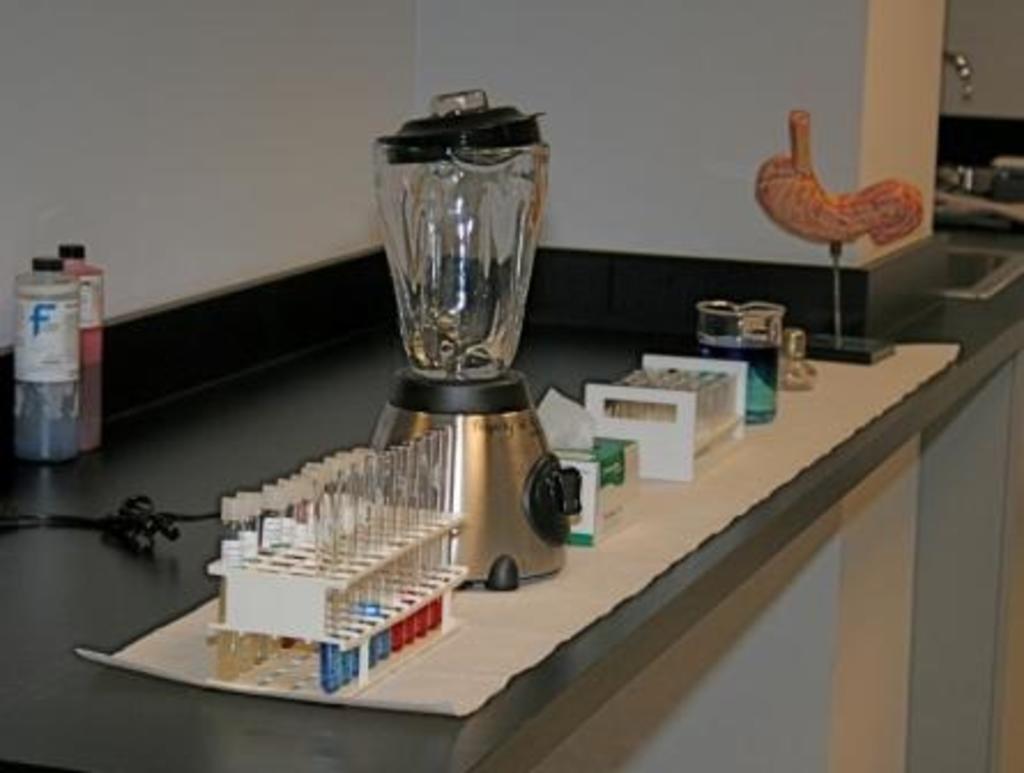Please provide a concise description of this image. I can see the test tubes, mixer with a jar, beaker and few other objects on the table. This looks like a cable. Here is the wall. In the background, that looks like a sink with a tap. 